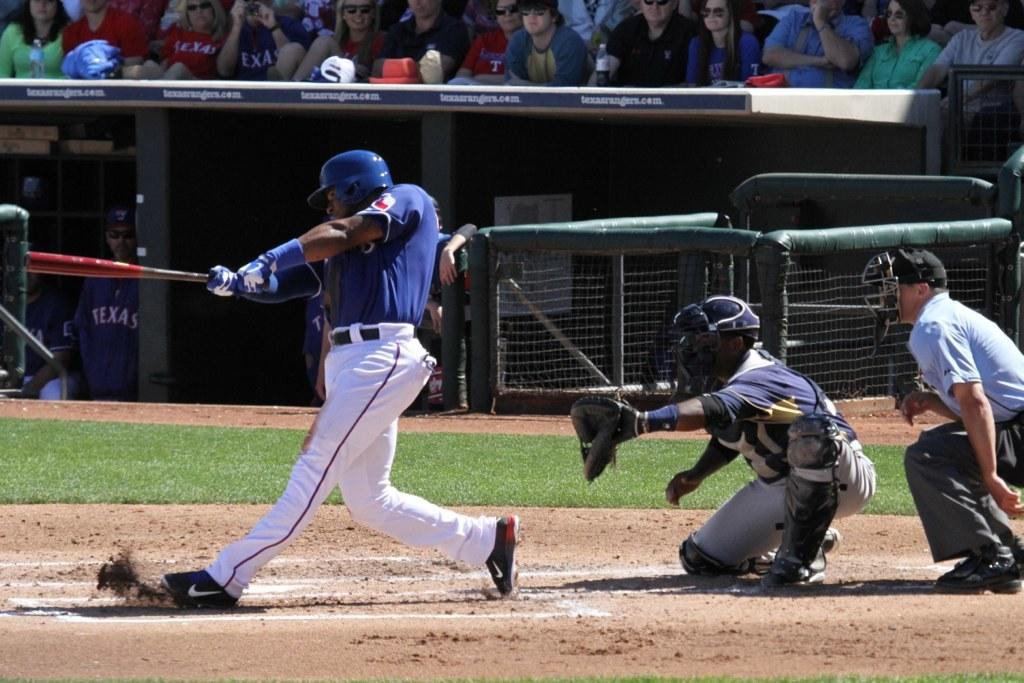Provide a one-sentence caption for the provided image. A baseball player for Texas is swinging at a pitch. 